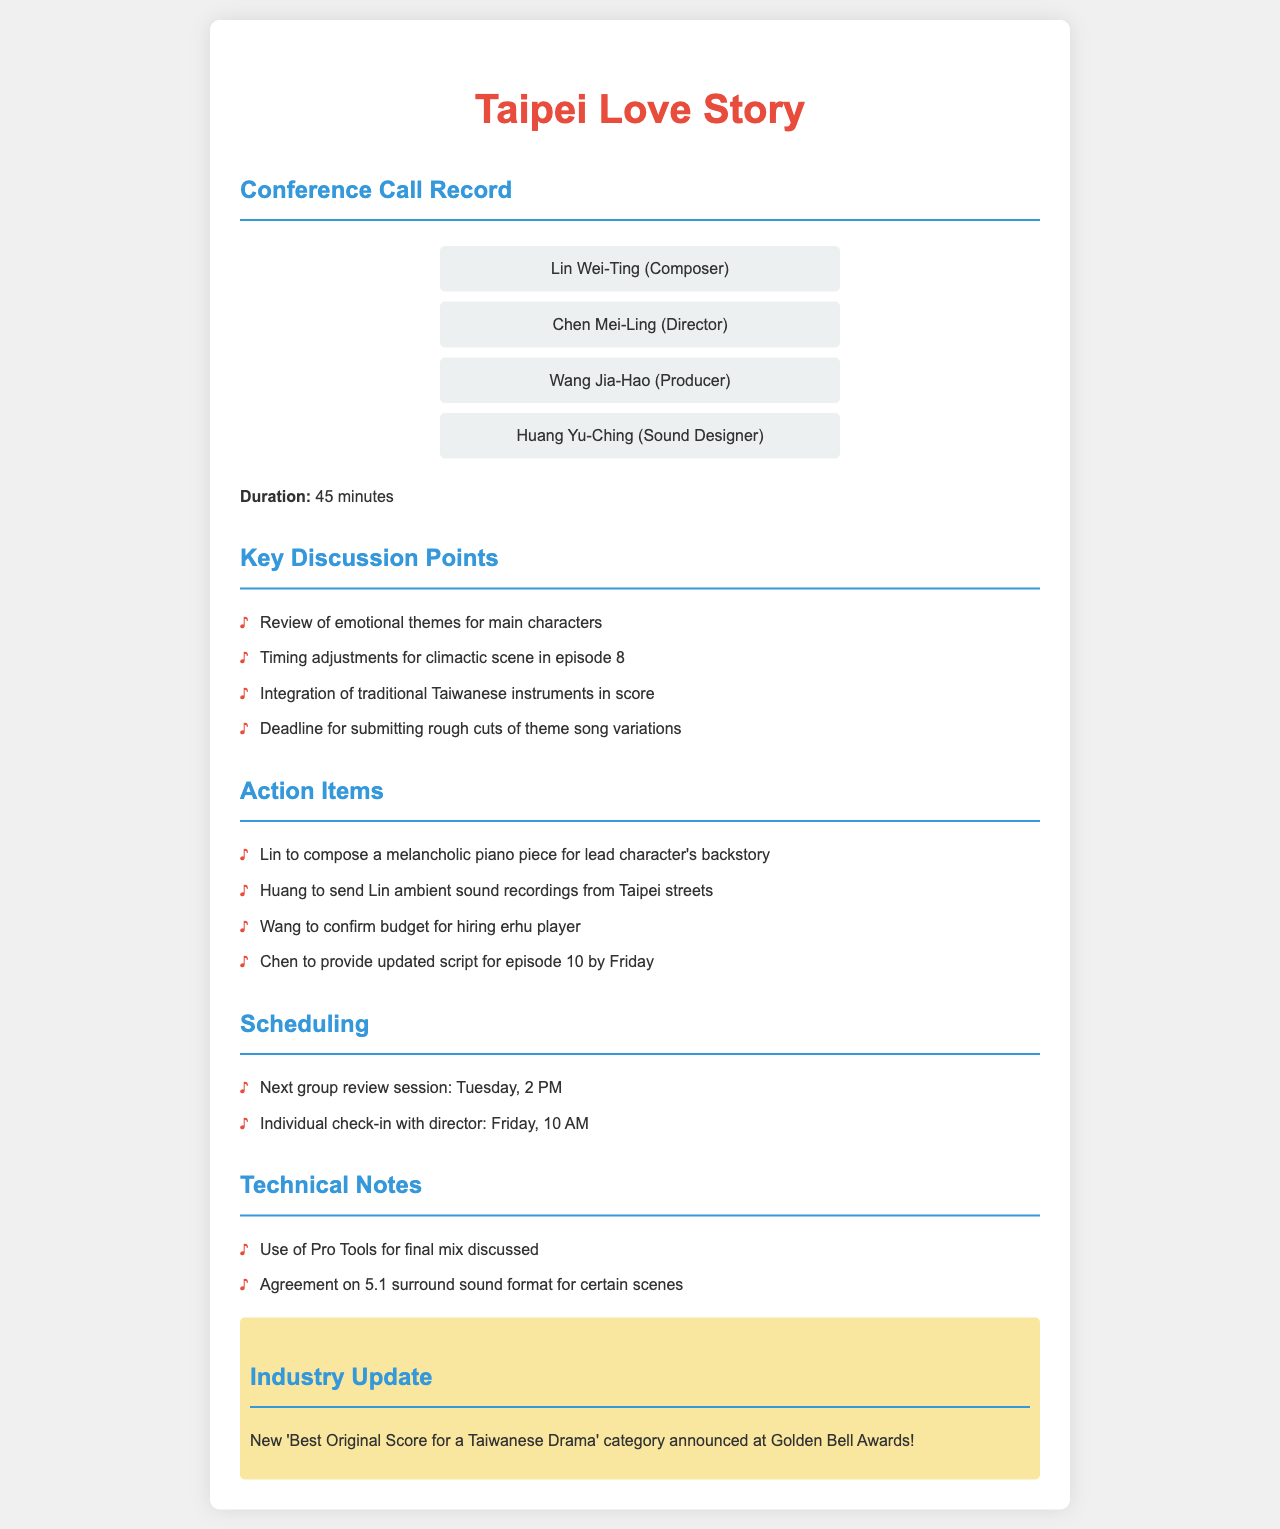What is the duration of the conference call? The document mentions that the duration of the call was 45 minutes.
Answer: 45 minutes Who is responsible for composing the melancholic piano piece? The action item states that Lin is to compose the piece.
Answer: Lin When is the next group review session scheduled? The document notes that the next group review session is on Tuesday at 2 PM.
Answer: Tuesday, 2 PM What instrument's player confirmation is Wang responsible for? The action item indicates that Wang needs to confirm the budget for hiring an erhu player.
Answer: Erhu player What software was discussed for the final mix? The technical notes mention that Pro Tools was discussed for use in the final mix.
Answer: Pro Tools Which character's backstory is the piano piece for? The action item specifies that the piece is for the lead character's backstory.
Answer: Lead character What update is highlighted in the document? The highlight section announces the new award category at the Golden Bell Awards.
Answer: New 'Best Original Score for a Taiwanese Drama' category What sound recordings is Huang sending to Lin? The action item states that Huang will send ambient sound recordings from Taipei streets.
Answer: Ambient sound recordings from Taipei streets Who is the sound designer mentioned in the call? The participant list includes Huang Yu-Ching as the sound designer.
Answer: Huang Yu-Ching 